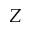Convert formula to latex. <formula><loc_0><loc_0><loc_500><loc_500>Z</formula> 